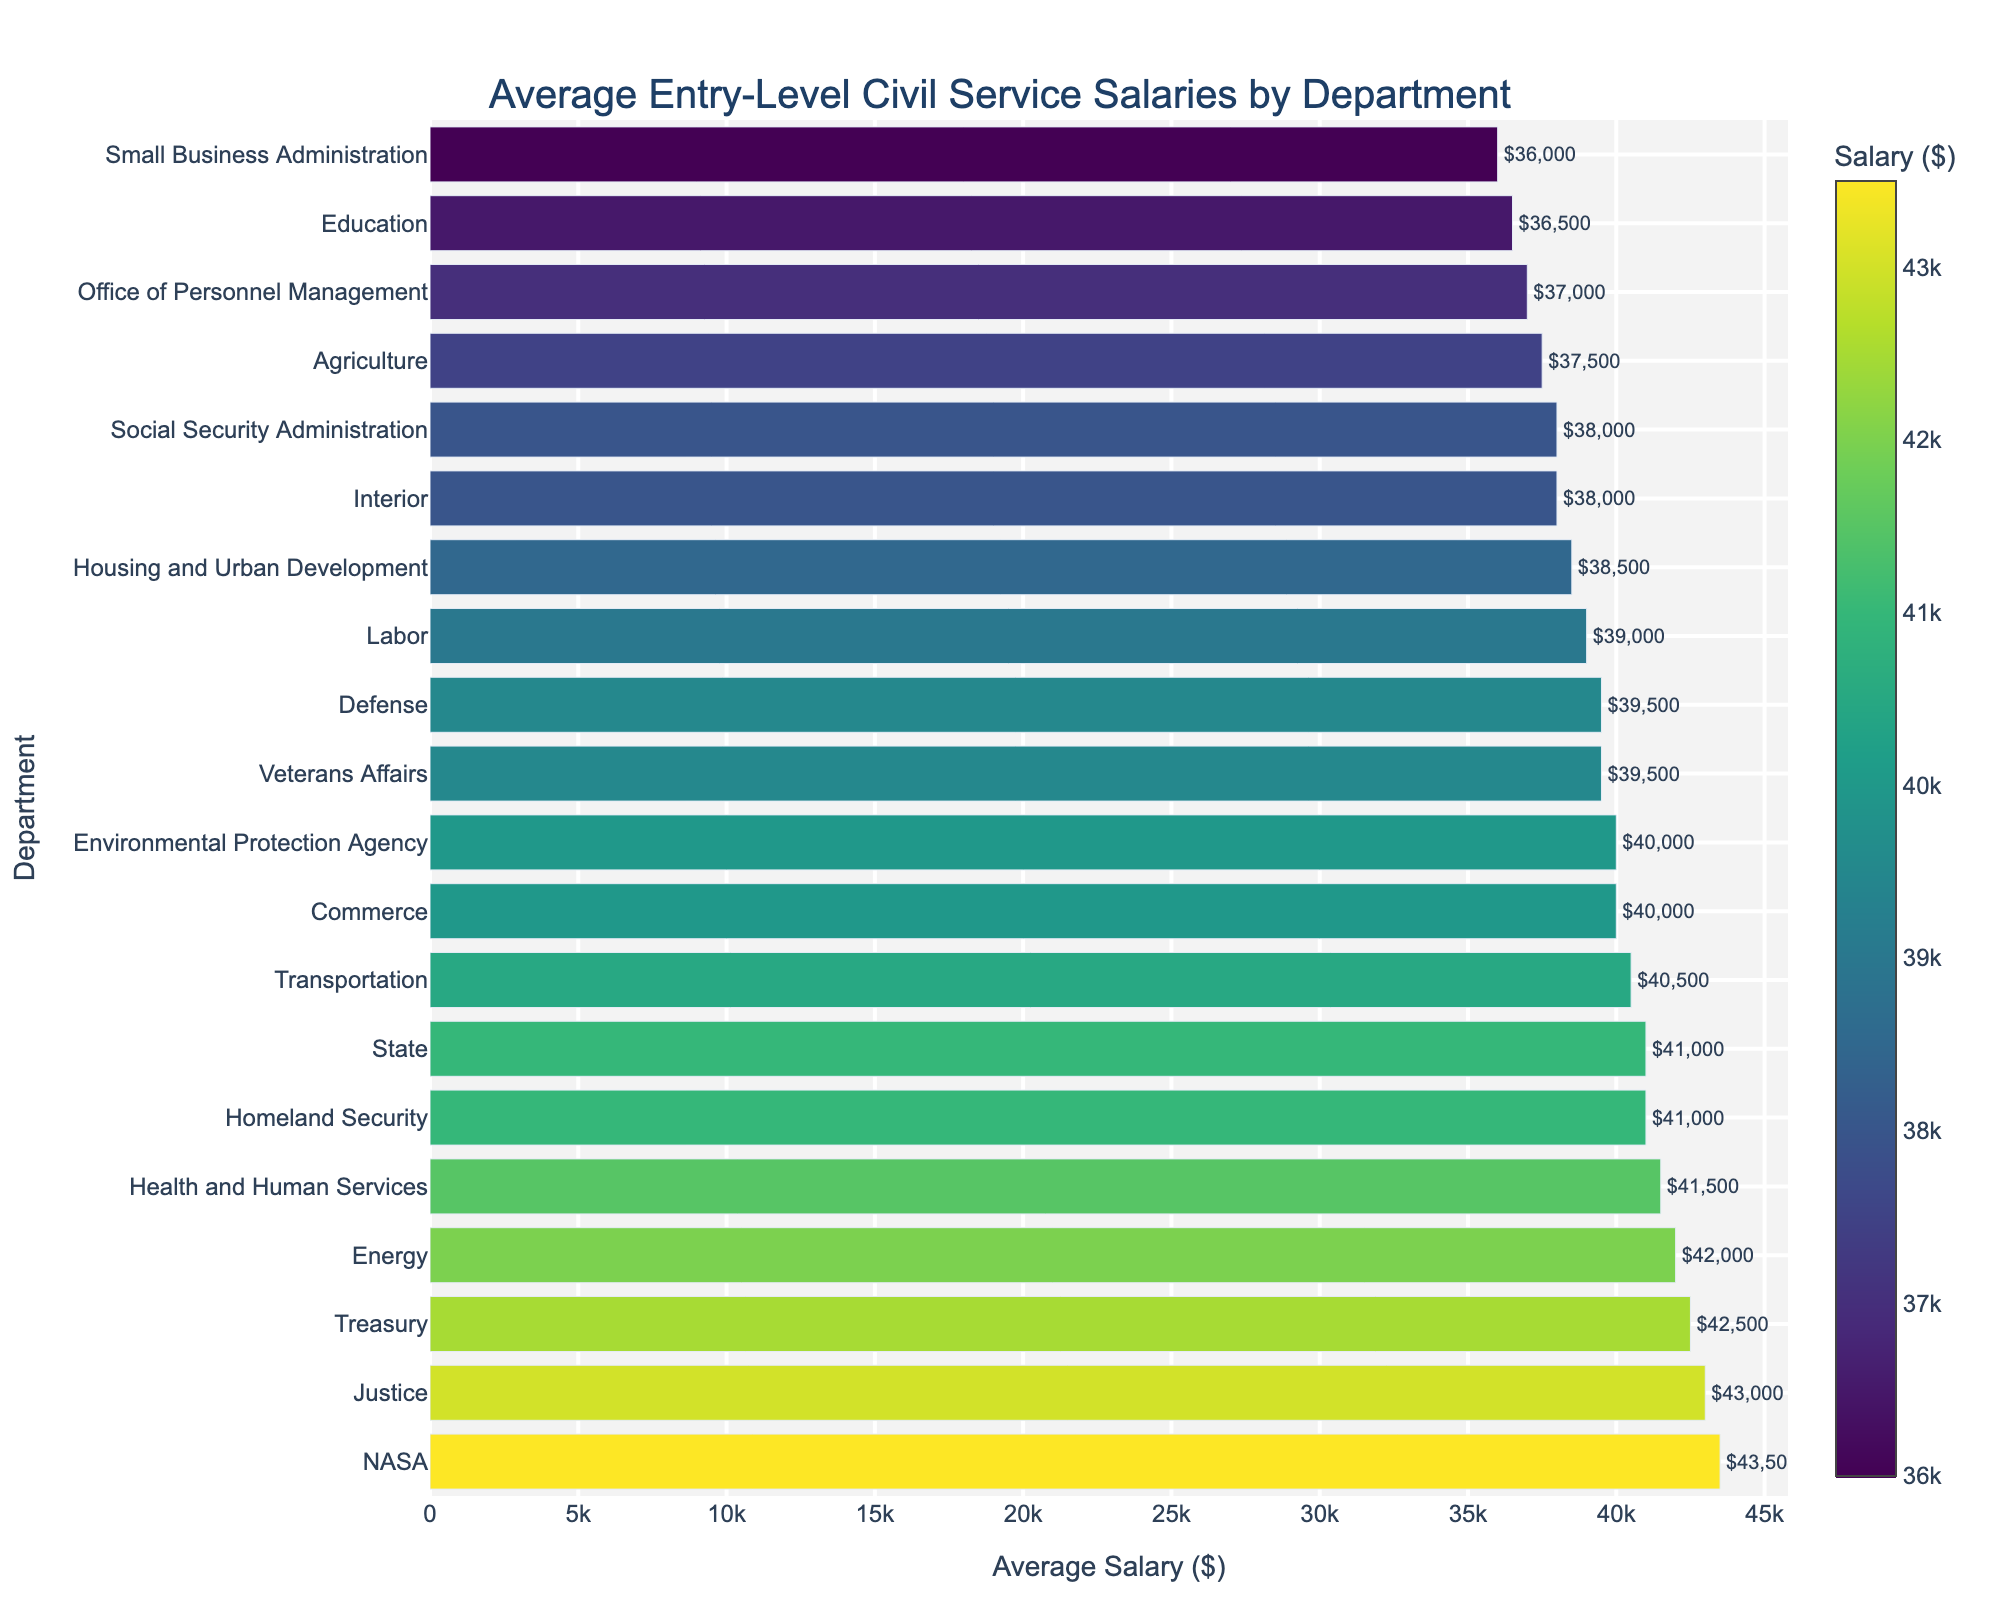Which department has the highest average entry-level salary? The bar representing NASA is the longest in the chart, indicating it has the highest value.
Answer: NASA Which department has the lowest average entry-level salary? The bar representing the Small Business Administration is the shortest in the chart, indicating it has the lowest value.
Answer: Small Business Administration How much more is the average salary of the Justice department compared to the Defense department? The average salary in the Justice department is 43000 and in the Defense department is 39500. The difference is 43000 - 39500.
Answer: 3500 Which departments have an average salary equal to or greater than $40000 but less than $42000? Departments with bars that fall between the $40000 and $42000 marks are State, Homeland Security, Transportation, Energy, Commerce, and Health and Human Services.
Answer: State, Homeland Security, Transportation, Commerce, and Health and Human Services How much is the average salary difference between the highest and lowest paid departments? The highest average salary is from NASA, which is $43500, and the lowest average salary is from the Small Business Administration, which is $36000. The difference is 43500 - 36000.
Answer: 7500 Which department is the median in terms of average salary? When departments are sorted by average salary, the middle department is Defense, which falls exactly halfway in the ordered list.
Answer: Defense If you combine the average salaries of the Interior and Agriculture departments, what would be their total? The average salaries are 38000 and 37500 respectively. Adding them results in 38000 + 37500.
Answer: 75500 Which two departments have the most similar average salaries? The Health and Human Services and Homeland Security departments have salaries of $41500 and $41000 respectively, showing a difference of only $500.
Answer: Health and Human Services and Homeland Security 